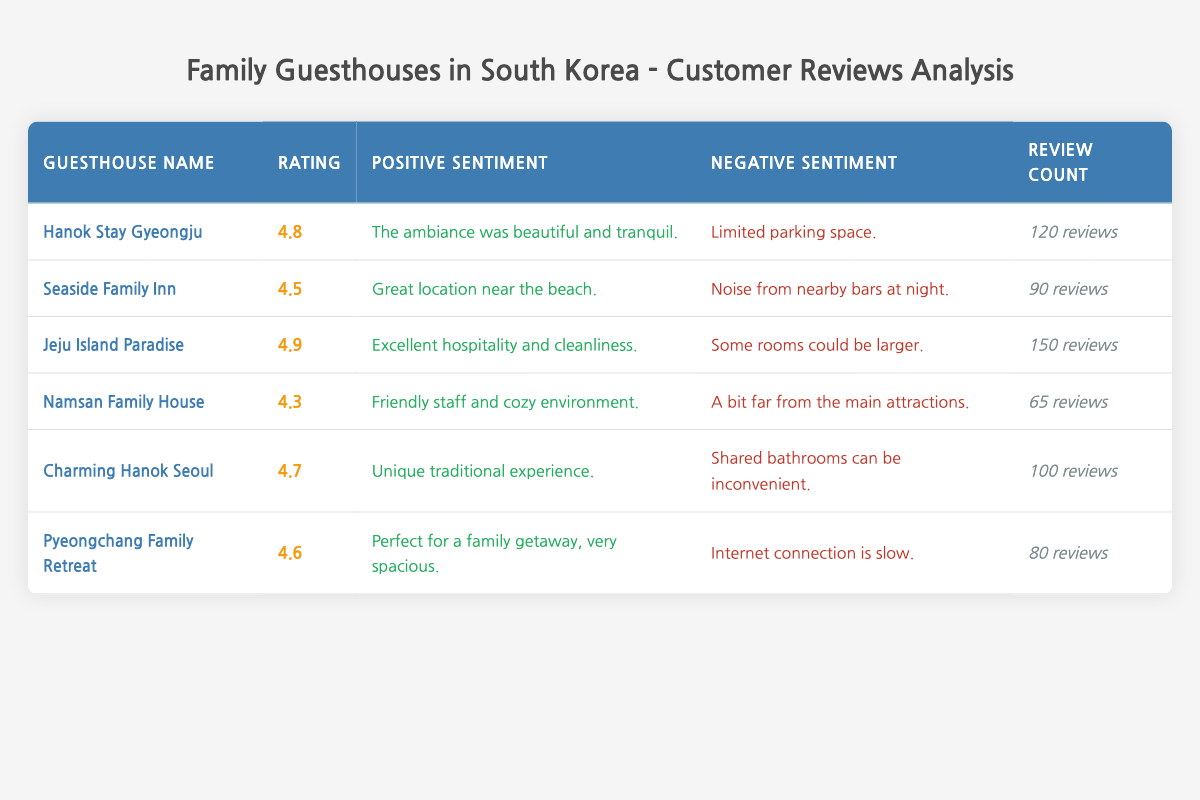What is the highest rating among the guesthouses? The rating column indicates that "Jeju Island Paradise" has the highest rating at 4.9.
Answer: 4.9 Which guesthouse has the most reviews? By examining the review count, "Jeju Island Paradise" has the most reviews, totaling 150.
Answer: Jeju Island Paradise How many guesthouses have a rating of 4.5 or higher? There are five guesthouses with ratings above 4.5, specifically: Hanok Stay Gyeongju (4.8), Jeju Island Paradise (4.9), Charming Hanok Seoul (4.7), Pyeongchang Family Retreat (4.6), and Seaside Family Inn (4.5).
Answer: 5 What is the average rating of the guesthouses listed? To find the average, we add the ratings together: (4.8 + 4.5 + 4.9 + 4.3 + 4.7 + 4.6) = 27.8. Then, divide by the number of guesthouses (6): 27.8 / 6 = approximately 4.63.
Answer: 4.63 Does "Namsan Family House" have more than 70 reviews? According to the review count, "Namsan Family House" has 65 reviews, which is less than 70.
Answer: No Which guesthouse has the least number of reviews and what is the count? Looking through the review counts, "Namsan Family House" has the least at 65 reviews.
Answer: 65 reviews How many guesthouses mention positive sentiments about cleanliness? "Jeju Island Paradise" mentions excellent cleanliness, while "Charming Hanok Seoul" emphasizes a unique experience, which isn't related to cleanliness. Therefore, only one guesthouse distinctly mentions cleanliness positively.
Answer: 1 If "Seaside Family Inn" were to receive 10 more reviews, how many would it have in total? Currently, "Seaside Family Inn" has 90 reviews. Adding 10 more would result in 90 + 10 = 100.
Answer: 100 Is it true that every guesthouse has a positive sentiment related to the environment? Examining the positive sentiments, "Seaside Family Inn" mentions location, not environment, while "Namsan Family House" refers to a cozy environment, but this does not apply universally. Therefore, the statement is false.
Answer: No 